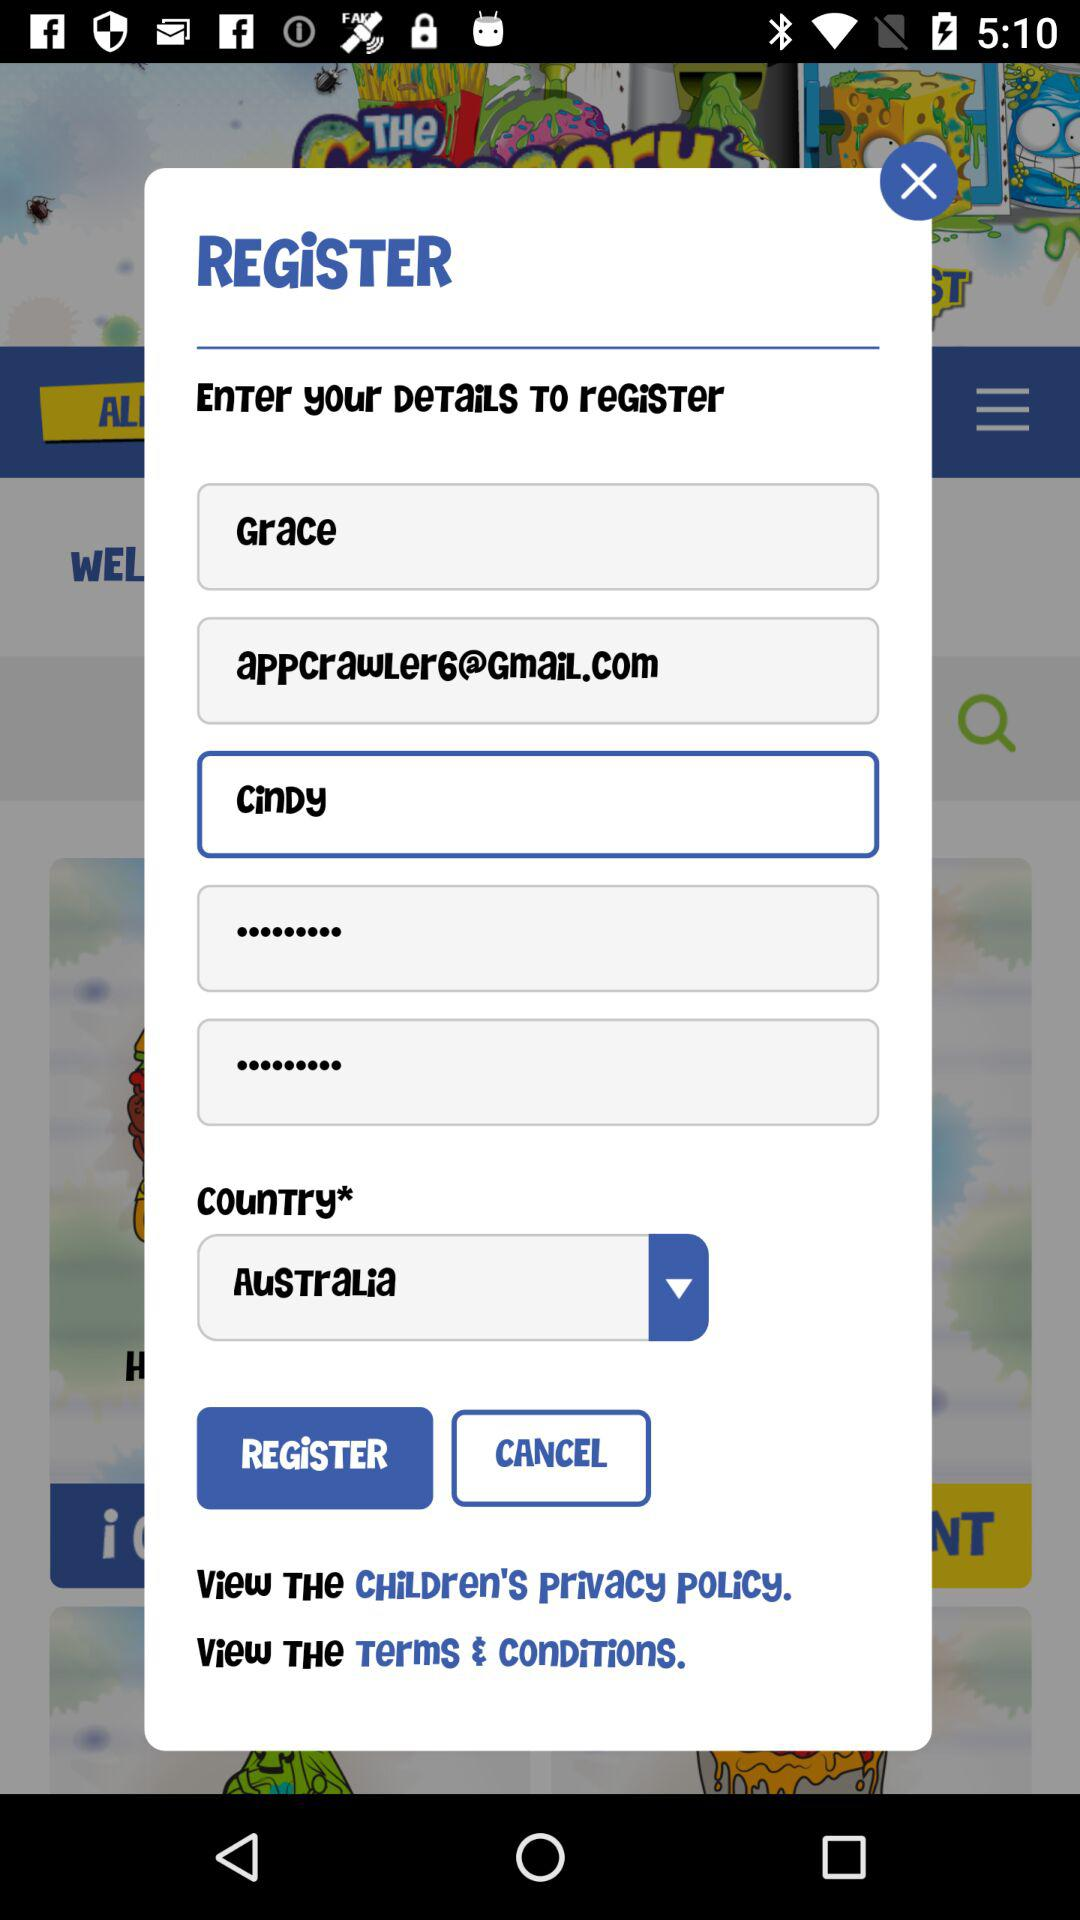What is the email address? The email address is appcrawler6@gmail.com. 